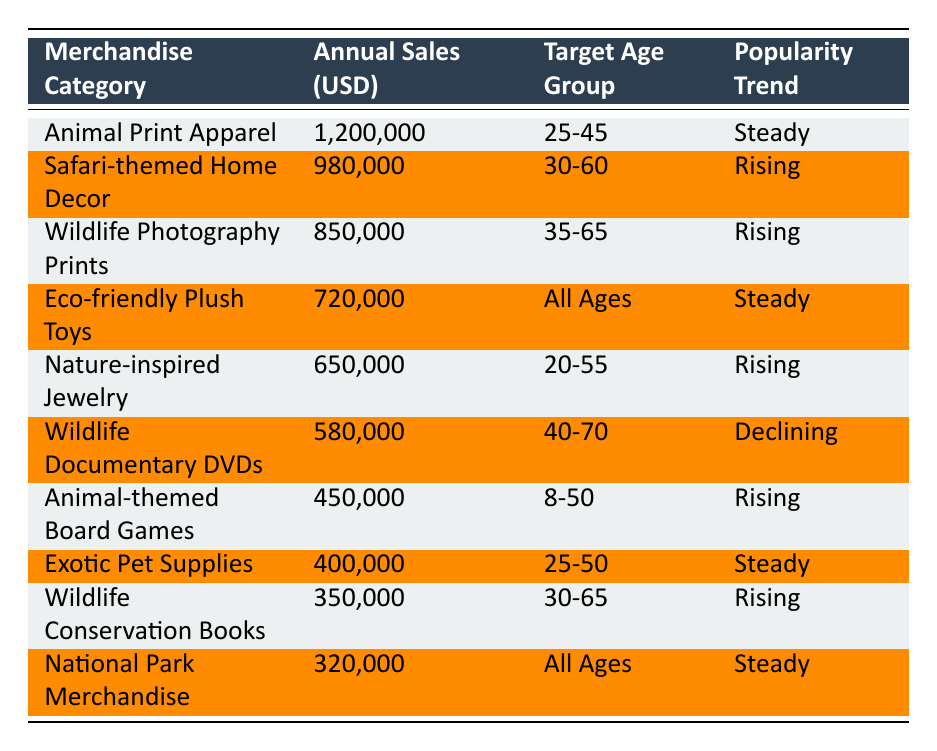What is the top-selling merchandise category? The top-selling category is "Animal Print Apparel" with annual sales of 1,200,000 USD.
Answer: 1,200,000 USD Which merchandise category targets the widest age group? The "Eco-friendly Plush Toys" and "National Park Merchandise" both target "All Ages."
Answer: All Ages What is the total annual sales of the merchandise categories that are rising in popularity? The categories that are rising are "Safari-themed Home Decor," "Wildlife Photography Prints," "Nature-inspired Jewelry," "Animal-themed Board Games," and "Wildlife Conservation Books." Their total sales is 980,000 + 850,000 + 650,000 + 450,000 + 350,000 = 3,280,000 USD.
Answer: 3,280,000 USD Is there any merchandise category that sees declining popularity? Yes, the "Wildlife Documentary DVDs" category is experiencing a declining popularity trend.
Answer: Yes What is the average annual sales of merchandise categories targeting the age group 25-50? The categories targeting 25-50 are "Animal Print Apparel," "Exotic Pet Supplies," and "Animal-themed Board Games." Their annual sales are 1,200,000, 400,000, and 450,000, respectively. The average is (1,200,000 + 400,000 + 450,000) / 3 = 350,000 USD.
Answer: 350,000 USD How many categories have annual sales of less than 600,000 USD? The categories with sales less than 600,000 USD are "Wildlife Documentary DVDs," "Animal-themed Board Games," "Exotic Pet Supplies," "Wildlife Conservation Books," and "National Park Merchandise." This totals 5 categories.
Answer: 5 Which merchandise category has the lowest sales and what is that amount? The category with the lowest sales is "National Park Merchandise" with annual sales of 320,000 USD.
Answer: 320,000 USD How many categories have a steady popularity trend? The categories with a steady trend are "Animal Print Apparel," "Eco-friendly Plush Toys," "Exotic Pet Supplies," and "National Park Merchandise," totaling 4 categories.
Answer: 4 